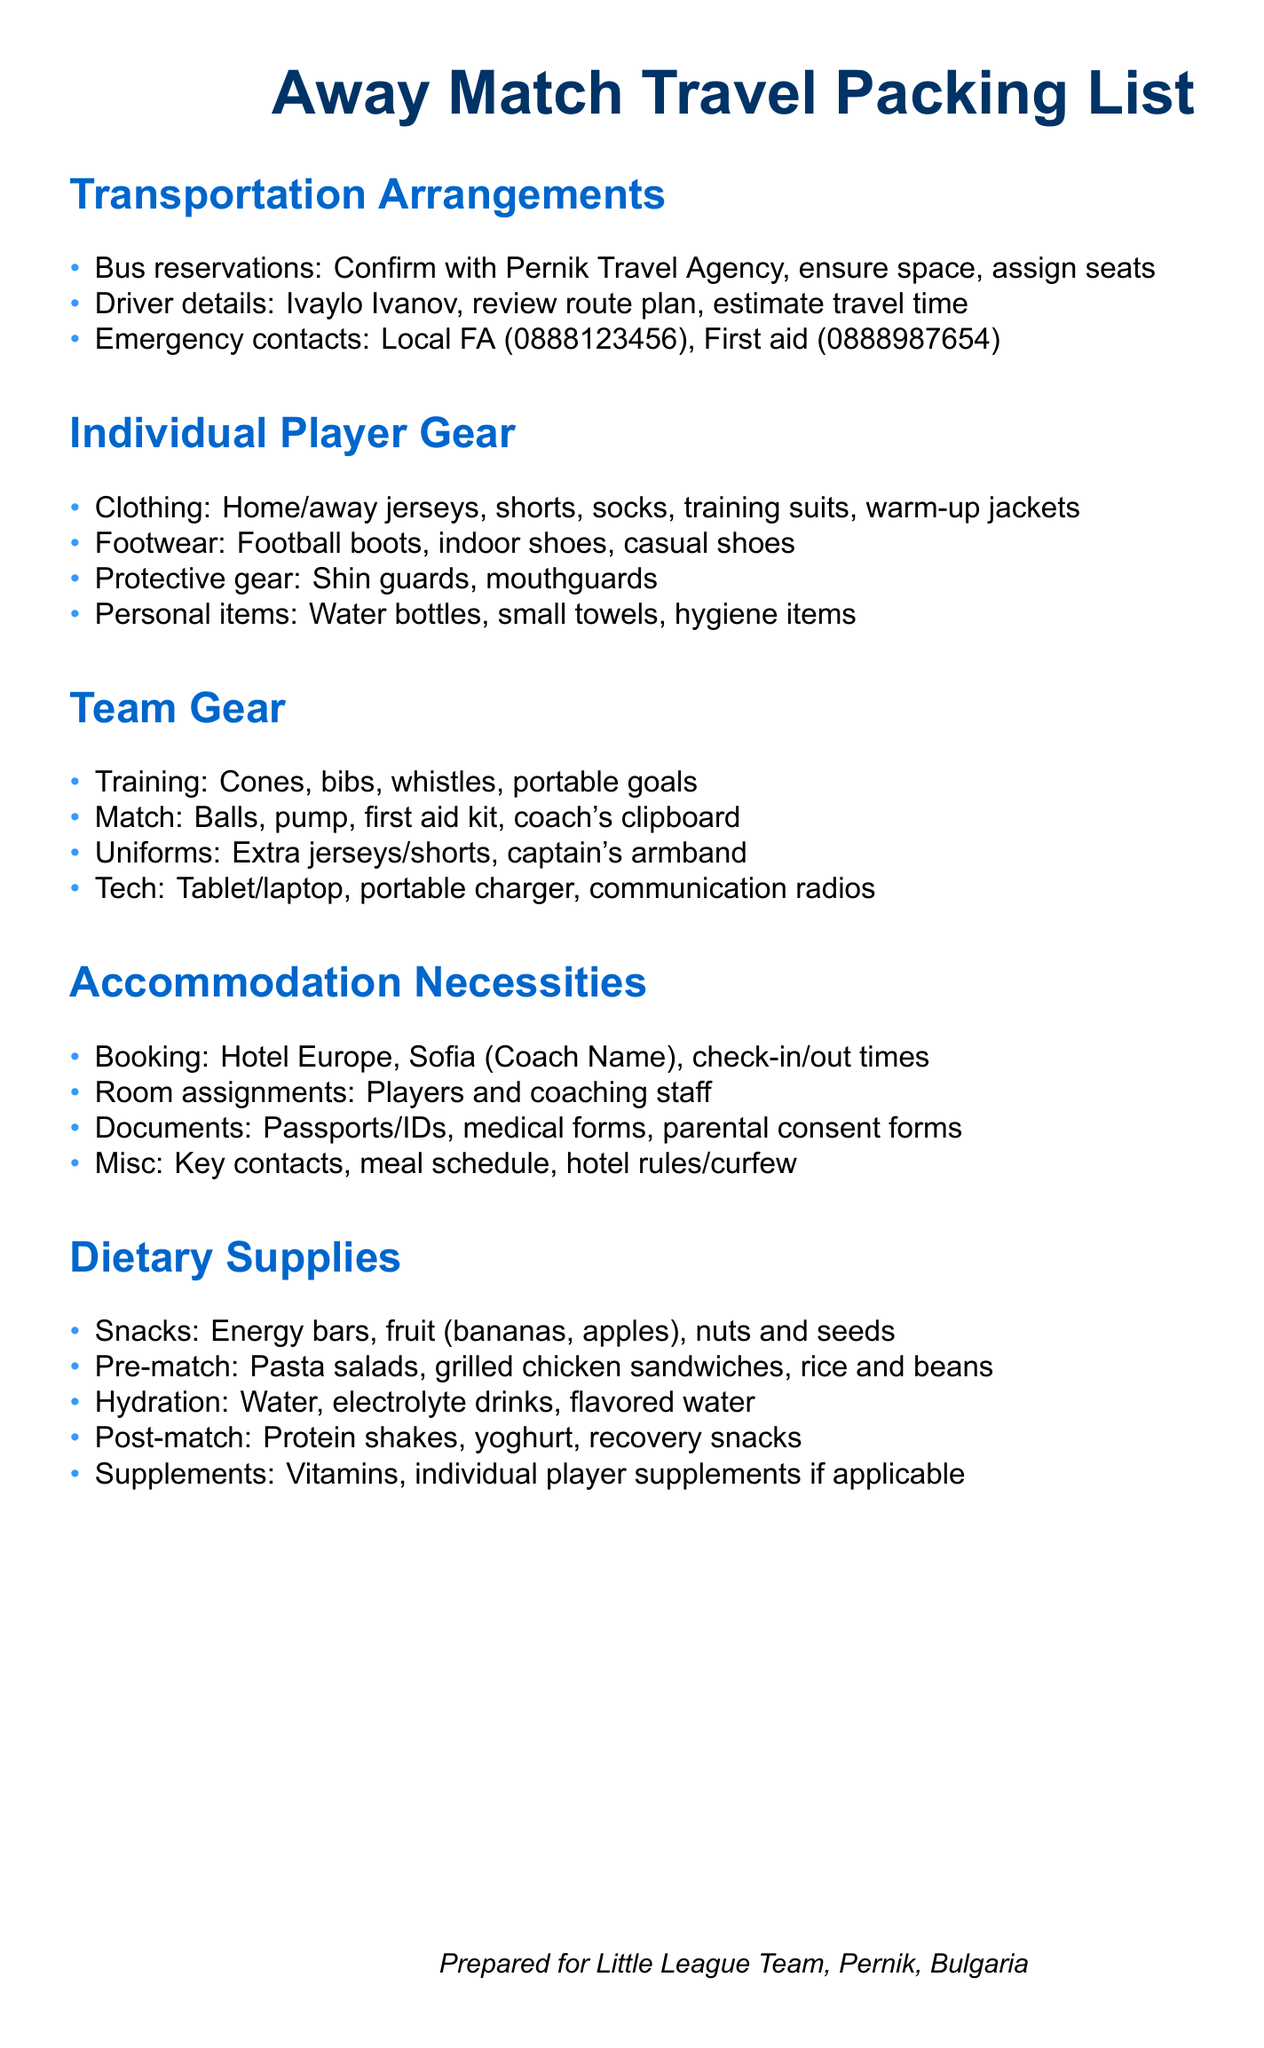What is the name of the travel agency? The travel agency responsible for bus reservations is mentioned as Pernik Travel Agency.
Answer: Pernik Travel Agency Who is the driver for the trip? The document specifies the driver as Ivaylo Ivanov.
Answer: Ivaylo Ivanov What items are included under protective gear? The packing list includes shin guards and mouthguards as part of the protective gear.
Answer: Shin guards, mouthguards Where will the team be staying in Sofia? The accommodation section states that the team will be booking Hotel Europe in Sofia.
Answer: Hotel Europe What snacks are listed for the trip? The dietary supplies include energy bars, fruit, nuts and seeds as snacks.
Answer: Energy bars, fruit, nuts and seeds What is the purpose of the first aid kit? The first aid kit is listed under team gear, indicating its importance for emergencies during the match.
Answer: Emergencies How many types of footwear should players bring? The document mentions three types of footwear: football boots, indoor shoes, and casual shoes.
Answer: Three What is the meal mentioned for pre-match dining? The dietary section lists pasta salads as part of the pre-match meal.
Answer: Pasta salads What should players carry for hydration? The hydration section specifies water and electrolyte drinks as essential supplies.
Answer: Water, electrolyte drinks 